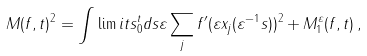<formula> <loc_0><loc_0><loc_500><loc_500>M ( f , t ) ^ { 2 } = \int \lim i t s _ { 0 } ^ { t } d s \varepsilon \sum _ { j } f ^ { \prime } ( \varepsilon x _ { j } ( \varepsilon ^ { - 1 } s ) ) ^ { 2 } + M _ { 1 } ^ { \varepsilon } ( f , t ) \, ,</formula> 